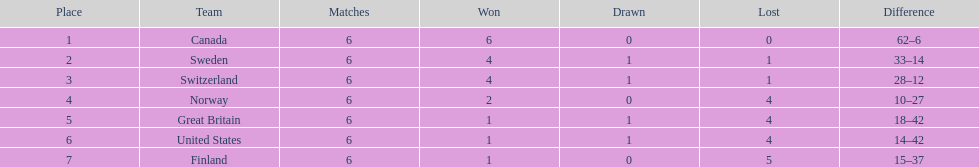In the 1951 world ice hockey championships, how many teams secured a minimum of two victories? 4. 